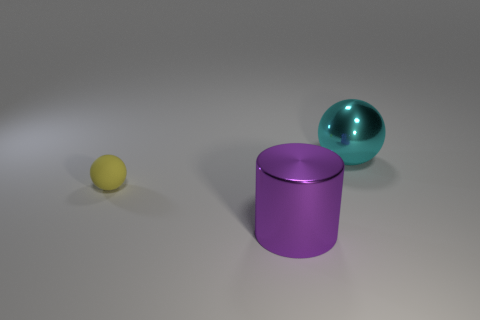How many large yellow shiny things have the same shape as the big cyan thing?
Ensure brevity in your answer.  0. The sphere that is the same material as the purple cylinder is what size?
Your answer should be compact. Large. The big metallic thing that is in front of the big thing behind the large purple metal object is what color?
Your response must be concise. Purple. There is a cyan object; is it the same shape as the object that is in front of the yellow sphere?
Keep it short and to the point. No. What number of other cylinders have the same size as the cylinder?
Provide a succinct answer. 0. There is another thing that is the same shape as the small yellow matte object; what is it made of?
Offer a very short reply. Metal. There is a metal thing that is on the left side of the big sphere; does it have the same color as the sphere that is left of the metallic cylinder?
Keep it short and to the point. No. The big thing in front of the tiny yellow thing has what shape?
Give a very brief answer. Cylinder. The small rubber sphere is what color?
Your answer should be compact. Yellow. What is the shape of the large object that is made of the same material as the cylinder?
Make the answer very short. Sphere. 